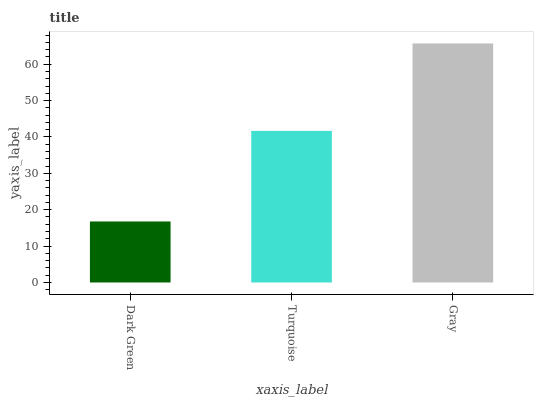Is Dark Green the minimum?
Answer yes or no. Yes. Is Gray the maximum?
Answer yes or no. Yes. Is Turquoise the minimum?
Answer yes or no. No. Is Turquoise the maximum?
Answer yes or no. No. Is Turquoise greater than Dark Green?
Answer yes or no. Yes. Is Dark Green less than Turquoise?
Answer yes or no. Yes. Is Dark Green greater than Turquoise?
Answer yes or no. No. Is Turquoise less than Dark Green?
Answer yes or no. No. Is Turquoise the high median?
Answer yes or no. Yes. Is Turquoise the low median?
Answer yes or no. Yes. Is Gray the high median?
Answer yes or no. No. Is Dark Green the low median?
Answer yes or no. No. 